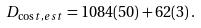<formula> <loc_0><loc_0><loc_500><loc_500>D _ { \cos t , e s t } = 1 0 8 4 ( 5 0 ) + 6 2 ( 3 ) \, .</formula> 